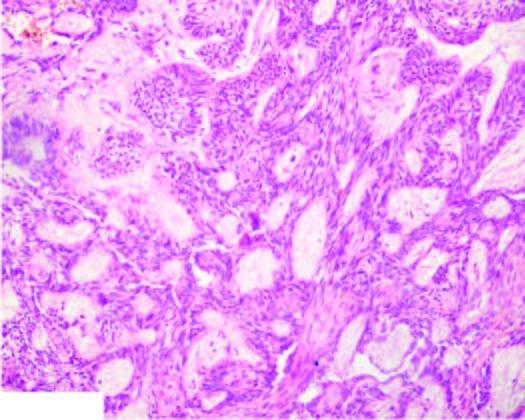re epithelial follicles composed of central area of stellate cells and peripheral layer of cuboidal or columnar cells?
Answer the question using a single word or phrase. Yes 